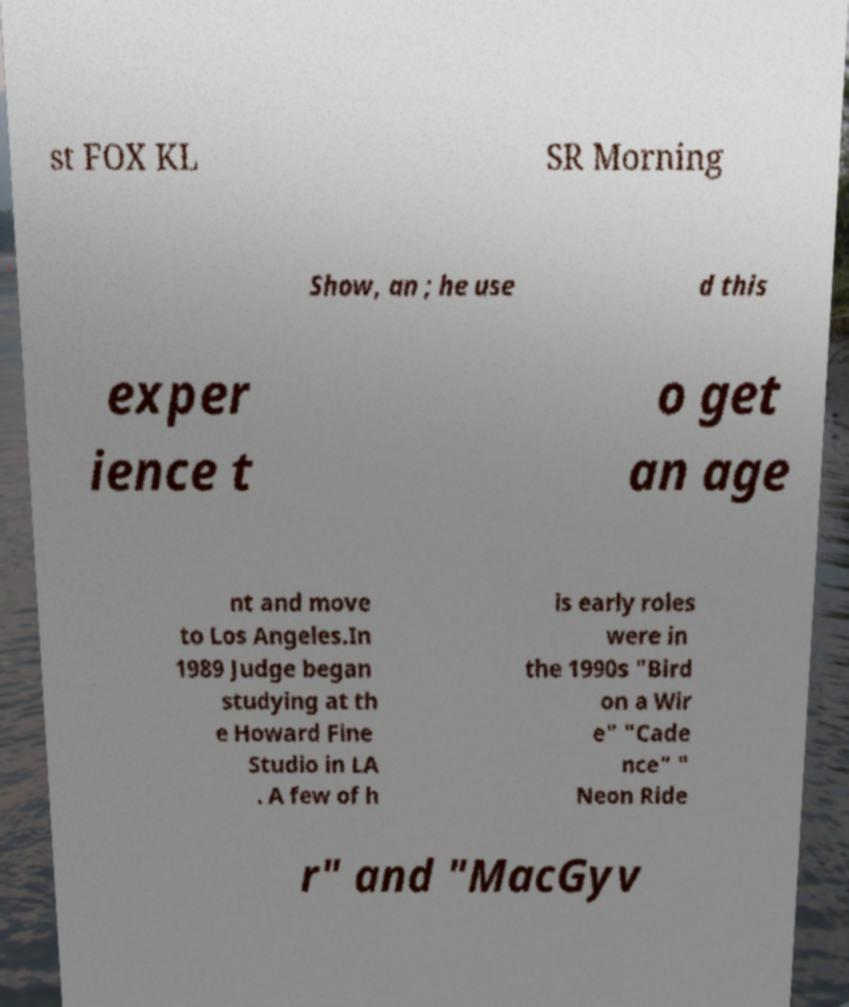There's text embedded in this image that I need extracted. Can you transcribe it verbatim? st FOX KL SR Morning Show, an ; he use d this exper ience t o get an age nt and move to Los Angeles.In 1989 Judge began studying at th e Howard Fine Studio in LA . A few of h is early roles were in the 1990s "Bird on a Wir e" "Cade nce" " Neon Ride r" and "MacGyv 